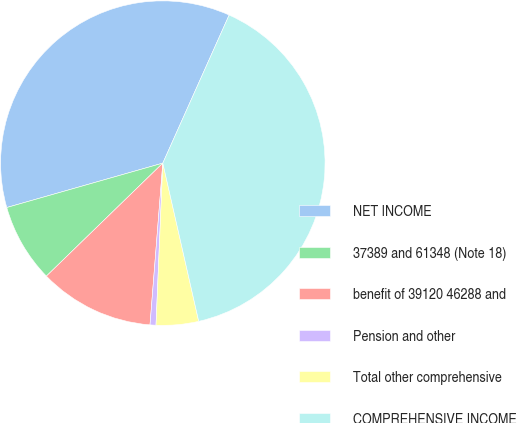Convert chart to OTSL. <chart><loc_0><loc_0><loc_500><loc_500><pie_chart><fcel>NET INCOME<fcel>37389 and 61348 (Note 18)<fcel>benefit of 39120 46288 and<fcel>Pension and other<fcel>Total other comprehensive<fcel>COMPREHENSIVE INCOME<nl><fcel>36.12%<fcel>7.85%<fcel>11.48%<fcel>0.59%<fcel>4.22%<fcel>39.75%<nl></chart> 